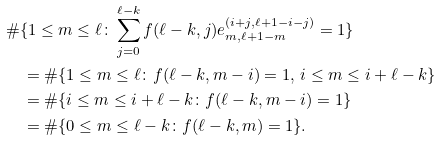<formula> <loc_0><loc_0><loc_500><loc_500>& \# \{ 1 \leq m \leq \ell \colon \sum _ { j = 0 } ^ { \ell - k } f ( \ell - k , j ) e _ { m , \ell + 1 - m } ^ { ( i + j , \ell + 1 - i - j ) } = 1 \} \\ & \quad = \# \{ 1 \leq m \leq \ell \colon f ( \ell - k , m - i ) = 1 , \, i \leq m \leq i + \ell - k \} \\ & \quad = \# \{ i \leq m \leq i + \ell - k \colon f ( \ell - k , m - i ) = 1 \} \\ & \quad = \# \{ 0 \leq m \leq \ell - k \colon f ( \ell - k , m ) = 1 \} . \\</formula> 